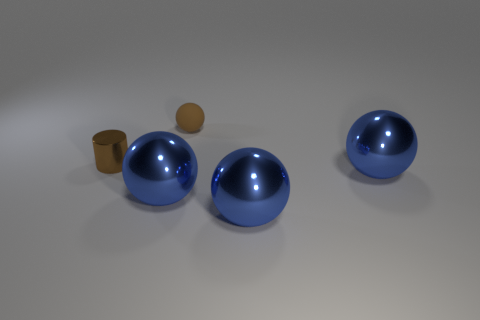Subtract all blue balls. How many were subtracted if there are1blue balls left? 2 Add 1 small shiny cylinders. How many objects exist? 6 Subtract all small brown balls. How many balls are left? 3 Subtract all brown balls. How many balls are left? 3 Subtract all spheres. How many objects are left? 1 Subtract all shiny spheres. Subtract all matte spheres. How many objects are left? 1 Add 1 big blue metallic balls. How many big blue metallic balls are left? 4 Add 5 brown cylinders. How many brown cylinders exist? 6 Subtract 0 gray cubes. How many objects are left? 5 Subtract 3 balls. How many balls are left? 1 